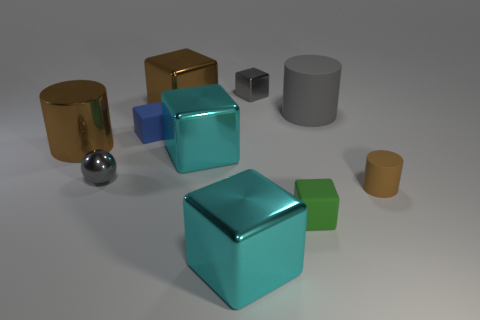Subtract all green blocks. How many blocks are left? 5 Subtract all large brown metallic blocks. How many blocks are left? 5 Subtract all purple blocks. Subtract all cyan spheres. How many blocks are left? 6 Subtract all spheres. How many objects are left? 9 Subtract all tiny green cubes. Subtract all metal cylinders. How many objects are left? 8 Add 7 large brown metal things. How many large brown metal things are left? 9 Add 6 small red cylinders. How many small red cylinders exist? 6 Subtract 0 blue cylinders. How many objects are left? 10 